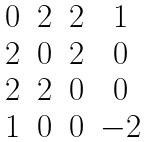<formula> <loc_0><loc_0><loc_500><loc_500>\begin{matrix} 0 & 2 & 2 & 1 \\ 2 & 0 & 2 & 0 \\ 2 & 2 & 0 & 0 \\ 1 & 0 & 0 & - 2 \end{matrix}</formula> 